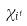<formula> <loc_0><loc_0><loc_500><loc_500>\chi _ { i ^ { t } }</formula> 